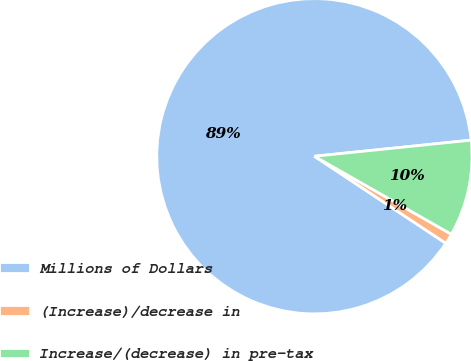Convert chart. <chart><loc_0><loc_0><loc_500><loc_500><pie_chart><fcel>Millions of Dollars<fcel>(Increase)/decrease in<fcel>Increase/(decrease) in pre-tax<nl><fcel>89.07%<fcel>1.07%<fcel>9.87%<nl></chart> 